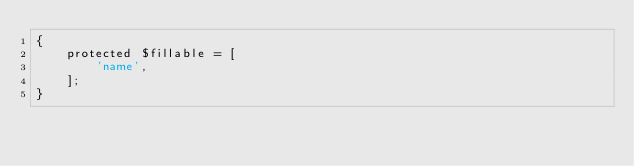<code> <loc_0><loc_0><loc_500><loc_500><_PHP_>{
    protected $fillable = [
        'name',
    ];
}
</code> 